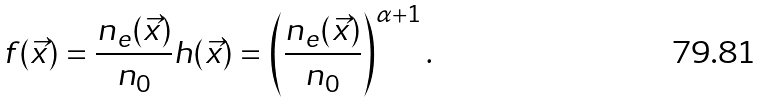Convert formula to latex. <formula><loc_0><loc_0><loc_500><loc_500>f ( \vec { x } ) = \frac { n _ { e } ( \vec { x } ) } { n _ { 0 } } h ( \vec { x } ) = \left ( \frac { n _ { e } ( \vec { x } ) } { n _ { 0 } } \right ) ^ { \alpha + 1 } .</formula> 